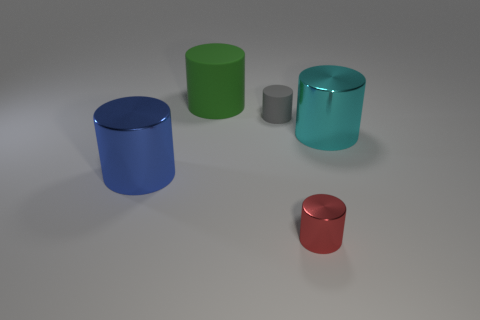Subtract all gray cylinders. Subtract all red blocks. How many cylinders are left? 4 Subtract all purple spheres. How many brown cylinders are left? 0 Add 5 big things. How many large greens exist? 0 Subtract all large blue rubber objects. Subtract all large green cylinders. How many objects are left? 4 Add 1 cyan metal cylinders. How many cyan metal cylinders are left? 2 Add 4 tiny gray matte things. How many tiny gray matte things exist? 5 Add 3 big green rubber balls. How many objects exist? 8 Subtract all blue cylinders. How many cylinders are left? 4 Subtract all cyan cylinders. How many cylinders are left? 4 Subtract 0 yellow cylinders. How many objects are left? 5 